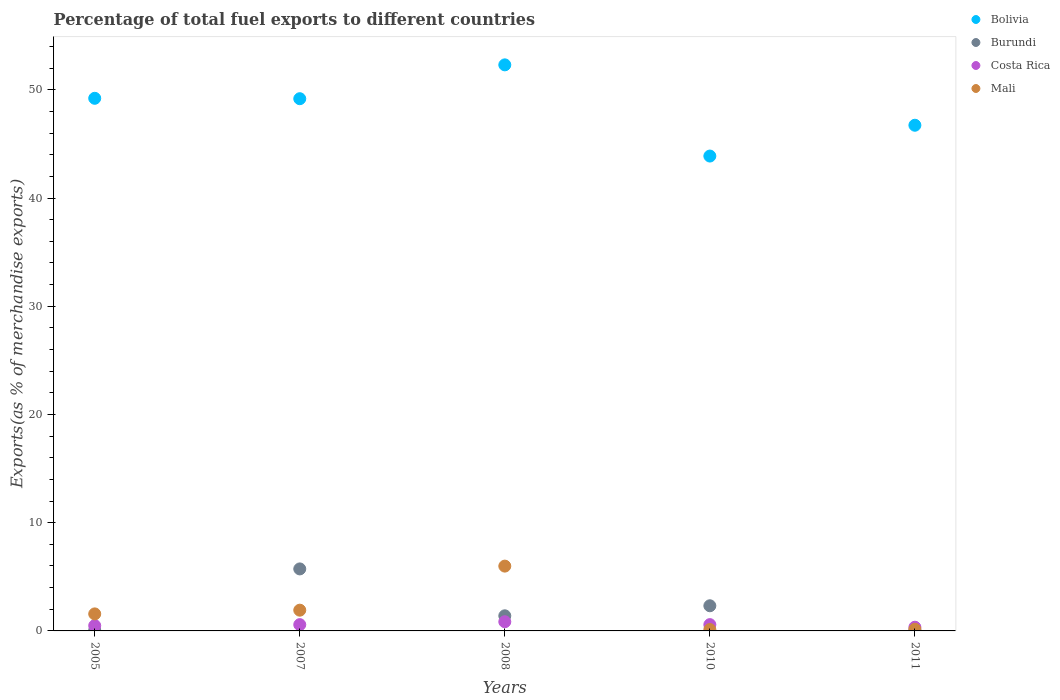What is the percentage of exports to different countries in Costa Rica in 2010?
Give a very brief answer. 0.58. Across all years, what is the maximum percentage of exports to different countries in Mali?
Your response must be concise. 5.99. Across all years, what is the minimum percentage of exports to different countries in Costa Rica?
Make the answer very short. 0.34. In which year was the percentage of exports to different countries in Costa Rica maximum?
Offer a terse response. 2008. In which year was the percentage of exports to different countries in Mali minimum?
Your answer should be very brief. 2010. What is the total percentage of exports to different countries in Burundi in the graph?
Offer a terse response. 9.55. What is the difference between the percentage of exports to different countries in Bolivia in 2010 and that in 2011?
Ensure brevity in your answer.  -2.85. What is the difference between the percentage of exports to different countries in Costa Rica in 2011 and the percentage of exports to different countries in Bolivia in 2010?
Ensure brevity in your answer.  -43.54. What is the average percentage of exports to different countries in Costa Rica per year?
Make the answer very short. 0.57. In the year 2010, what is the difference between the percentage of exports to different countries in Bolivia and percentage of exports to different countries in Mali?
Give a very brief answer. 43.75. In how many years, is the percentage of exports to different countries in Costa Rica greater than 46 %?
Make the answer very short. 0. What is the ratio of the percentage of exports to different countries in Bolivia in 2010 to that in 2011?
Provide a succinct answer. 0.94. Is the percentage of exports to different countries in Mali in 2008 less than that in 2010?
Offer a terse response. No. What is the difference between the highest and the second highest percentage of exports to different countries in Burundi?
Ensure brevity in your answer.  3.41. What is the difference between the highest and the lowest percentage of exports to different countries in Mali?
Give a very brief answer. 5.86. In how many years, is the percentage of exports to different countries in Costa Rica greater than the average percentage of exports to different countries in Costa Rica taken over all years?
Offer a very short reply. 3. Is it the case that in every year, the sum of the percentage of exports to different countries in Mali and percentage of exports to different countries in Costa Rica  is greater than the percentage of exports to different countries in Bolivia?
Keep it short and to the point. No. Does the percentage of exports to different countries in Bolivia monotonically increase over the years?
Make the answer very short. No. Is the percentage of exports to different countries in Burundi strictly greater than the percentage of exports to different countries in Mali over the years?
Your response must be concise. No. Is the percentage of exports to different countries in Mali strictly less than the percentage of exports to different countries in Bolivia over the years?
Offer a very short reply. Yes. How many dotlines are there?
Make the answer very short. 4. How many years are there in the graph?
Provide a short and direct response. 5. Does the graph contain grids?
Offer a very short reply. No. Where does the legend appear in the graph?
Your response must be concise. Top right. How are the legend labels stacked?
Make the answer very short. Vertical. What is the title of the graph?
Your response must be concise. Percentage of total fuel exports to different countries. Does "Euro area" appear as one of the legend labels in the graph?
Offer a terse response. No. What is the label or title of the Y-axis?
Provide a succinct answer. Exports(as % of merchandise exports). What is the Exports(as % of merchandise exports) of Bolivia in 2005?
Your answer should be compact. 49.21. What is the Exports(as % of merchandise exports) in Burundi in 2005?
Your answer should be very brief. 0.06. What is the Exports(as % of merchandise exports) of Costa Rica in 2005?
Ensure brevity in your answer.  0.49. What is the Exports(as % of merchandise exports) in Mali in 2005?
Offer a terse response. 1.57. What is the Exports(as % of merchandise exports) in Bolivia in 2007?
Ensure brevity in your answer.  49.18. What is the Exports(as % of merchandise exports) in Burundi in 2007?
Ensure brevity in your answer.  5.73. What is the Exports(as % of merchandise exports) of Costa Rica in 2007?
Your answer should be very brief. 0.58. What is the Exports(as % of merchandise exports) in Mali in 2007?
Provide a short and direct response. 1.92. What is the Exports(as % of merchandise exports) in Bolivia in 2008?
Offer a terse response. 52.3. What is the Exports(as % of merchandise exports) in Burundi in 2008?
Provide a succinct answer. 1.4. What is the Exports(as % of merchandise exports) of Costa Rica in 2008?
Your answer should be very brief. 0.85. What is the Exports(as % of merchandise exports) of Mali in 2008?
Offer a terse response. 5.99. What is the Exports(as % of merchandise exports) in Bolivia in 2010?
Keep it short and to the point. 43.88. What is the Exports(as % of merchandise exports) in Burundi in 2010?
Make the answer very short. 2.32. What is the Exports(as % of merchandise exports) of Costa Rica in 2010?
Provide a succinct answer. 0.58. What is the Exports(as % of merchandise exports) of Mali in 2010?
Your answer should be very brief. 0.13. What is the Exports(as % of merchandise exports) in Bolivia in 2011?
Provide a short and direct response. 46.72. What is the Exports(as % of merchandise exports) of Burundi in 2011?
Offer a very short reply. 0.04. What is the Exports(as % of merchandise exports) of Costa Rica in 2011?
Offer a very short reply. 0.34. What is the Exports(as % of merchandise exports) in Mali in 2011?
Your answer should be compact. 0.15. Across all years, what is the maximum Exports(as % of merchandise exports) of Bolivia?
Offer a very short reply. 52.3. Across all years, what is the maximum Exports(as % of merchandise exports) of Burundi?
Make the answer very short. 5.73. Across all years, what is the maximum Exports(as % of merchandise exports) in Costa Rica?
Your answer should be compact. 0.85. Across all years, what is the maximum Exports(as % of merchandise exports) in Mali?
Your answer should be very brief. 5.99. Across all years, what is the minimum Exports(as % of merchandise exports) of Bolivia?
Give a very brief answer. 43.88. Across all years, what is the minimum Exports(as % of merchandise exports) of Burundi?
Your response must be concise. 0.04. Across all years, what is the minimum Exports(as % of merchandise exports) in Costa Rica?
Your answer should be very brief. 0.34. Across all years, what is the minimum Exports(as % of merchandise exports) in Mali?
Make the answer very short. 0.13. What is the total Exports(as % of merchandise exports) in Bolivia in the graph?
Provide a succinct answer. 241.3. What is the total Exports(as % of merchandise exports) in Burundi in the graph?
Ensure brevity in your answer.  9.55. What is the total Exports(as % of merchandise exports) of Costa Rica in the graph?
Offer a terse response. 2.84. What is the total Exports(as % of merchandise exports) in Mali in the graph?
Your response must be concise. 9.76. What is the difference between the Exports(as % of merchandise exports) in Bolivia in 2005 and that in 2007?
Make the answer very short. 0.04. What is the difference between the Exports(as % of merchandise exports) of Burundi in 2005 and that in 2007?
Your response must be concise. -5.67. What is the difference between the Exports(as % of merchandise exports) in Costa Rica in 2005 and that in 2007?
Make the answer very short. -0.09. What is the difference between the Exports(as % of merchandise exports) of Mali in 2005 and that in 2007?
Make the answer very short. -0.34. What is the difference between the Exports(as % of merchandise exports) in Bolivia in 2005 and that in 2008?
Your answer should be compact. -3.09. What is the difference between the Exports(as % of merchandise exports) in Burundi in 2005 and that in 2008?
Offer a very short reply. -1.33. What is the difference between the Exports(as % of merchandise exports) of Costa Rica in 2005 and that in 2008?
Provide a succinct answer. -0.36. What is the difference between the Exports(as % of merchandise exports) of Mali in 2005 and that in 2008?
Give a very brief answer. -4.42. What is the difference between the Exports(as % of merchandise exports) of Bolivia in 2005 and that in 2010?
Ensure brevity in your answer.  5.34. What is the difference between the Exports(as % of merchandise exports) of Burundi in 2005 and that in 2010?
Give a very brief answer. -2.26. What is the difference between the Exports(as % of merchandise exports) of Costa Rica in 2005 and that in 2010?
Ensure brevity in your answer.  -0.09. What is the difference between the Exports(as % of merchandise exports) of Mali in 2005 and that in 2010?
Offer a very short reply. 1.45. What is the difference between the Exports(as % of merchandise exports) of Bolivia in 2005 and that in 2011?
Ensure brevity in your answer.  2.49. What is the difference between the Exports(as % of merchandise exports) of Burundi in 2005 and that in 2011?
Provide a succinct answer. 0.03. What is the difference between the Exports(as % of merchandise exports) in Costa Rica in 2005 and that in 2011?
Offer a terse response. 0.15. What is the difference between the Exports(as % of merchandise exports) of Mali in 2005 and that in 2011?
Keep it short and to the point. 1.42. What is the difference between the Exports(as % of merchandise exports) in Bolivia in 2007 and that in 2008?
Offer a very short reply. -3.13. What is the difference between the Exports(as % of merchandise exports) of Burundi in 2007 and that in 2008?
Make the answer very short. 4.33. What is the difference between the Exports(as % of merchandise exports) of Costa Rica in 2007 and that in 2008?
Offer a very short reply. -0.27. What is the difference between the Exports(as % of merchandise exports) of Mali in 2007 and that in 2008?
Your response must be concise. -4.07. What is the difference between the Exports(as % of merchandise exports) in Bolivia in 2007 and that in 2010?
Provide a short and direct response. 5.3. What is the difference between the Exports(as % of merchandise exports) of Burundi in 2007 and that in 2010?
Keep it short and to the point. 3.41. What is the difference between the Exports(as % of merchandise exports) in Costa Rica in 2007 and that in 2010?
Offer a terse response. -0. What is the difference between the Exports(as % of merchandise exports) of Mali in 2007 and that in 2010?
Your answer should be compact. 1.79. What is the difference between the Exports(as % of merchandise exports) in Bolivia in 2007 and that in 2011?
Offer a very short reply. 2.45. What is the difference between the Exports(as % of merchandise exports) of Burundi in 2007 and that in 2011?
Give a very brief answer. 5.69. What is the difference between the Exports(as % of merchandise exports) of Costa Rica in 2007 and that in 2011?
Keep it short and to the point. 0.24. What is the difference between the Exports(as % of merchandise exports) in Mali in 2007 and that in 2011?
Keep it short and to the point. 1.76. What is the difference between the Exports(as % of merchandise exports) in Bolivia in 2008 and that in 2010?
Provide a short and direct response. 8.43. What is the difference between the Exports(as % of merchandise exports) in Burundi in 2008 and that in 2010?
Offer a very short reply. -0.93. What is the difference between the Exports(as % of merchandise exports) in Costa Rica in 2008 and that in 2010?
Ensure brevity in your answer.  0.27. What is the difference between the Exports(as % of merchandise exports) of Mali in 2008 and that in 2010?
Offer a very short reply. 5.86. What is the difference between the Exports(as % of merchandise exports) of Bolivia in 2008 and that in 2011?
Your answer should be compact. 5.58. What is the difference between the Exports(as % of merchandise exports) of Burundi in 2008 and that in 2011?
Offer a very short reply. 1.36. What is the difference between the Exports(as % of merchandise exports) of Costa Rica in 2008 and that in 2011?
Make the answer very short. 0.51. What is the difference between the Exports(as % of merchandise exports) of Mali in 2008 and that in 2011?
Provide a succinct answer. 5.83. What is the difference between the Exports(as % of merchandise exports) in Bolivia in 2010 and that in 2011?
Make the answer very short. -2.85. What is the difference between the Exports(as % of merchandise exports) in Burundi in 2010 and that in 2011?
Give a very brief answer. 2.29. What is the difference between the Exports(as % of merchandise exports) of Costa Rica in 2010 and that in 2011?
Offer a terse response. 0.24. What is the difference between the Exports(as % of merchandise exports) of Mali in 2010 and that in 2011?
Keep it short and to the point. -0.03. What is the difference between the Exports(as % of merchandise exports) of Bolivia in 2005 and the Exports(as % of merchandise exports) of Burundi in 2007?
Your response must be concise. 43.48. What is the difference between the Exports(as % of merchandise exports) of Bolivia in 2005 and the Exports(as % of merchandise exports) of Costa Rica in 2007?
Your response must be concise. 48.63. What is the difference between the Exports(as % of merchandise exports) in Bolivia in 2005 and the Exports(as % of merchandise exports) in Mali in 2007?
Make the answer very short. 47.3. What is the difference between the Exports(as % of merchandise exports) in Burundi in 2005 and the Exports(as % of merchandise exports) in Costa Rica in 2007?
Your answer should be very brief. -0.52. What is the difference between the Exports(as % of merchandise exports) in Burundi in 2005 and the Exports(as % of merchandise exports) in Mali in 2007?
Your response must be concise. -1.85. What is the difference between the Exports(as % of merchandise exports) in Costa Rica in 2005 and the Exports(as % of merchandise exports) in Mali in 2007?
Provide a succinct answer. -1.43. What is the difference between the Exports(as % of merchandise exports) in Bolivia in 2005 and the Exports(as % of merchandise exports) in Burundi in 2008?
Provide a succinct answer. 47.82. What is the difference between the Exports(as % of merchandise exports) of Bolivia in 2005 and the Exports(as % of merchandise exports) of Costa Rica in 2008?
Offer a terse response. 48.37. What is the difference between the Exports(as % of merchandise exports) in Bolivia in 2005 and the Exports(as % of merchandise exports) in Mali in 2008?
Offer a very short reply. 43.23. What is the difference between the Exports(as % of merchandise exports) of Burundi in 2005 and the Exports(as % of merchandise exports) of Costa Rica in 2008?
Provide a short and direct response. -0.78. What is the difference between the Exports(as % of merchandise exports) in Burundi in 2005 and the Exports(as % of merchandise exports) in Mali in 2008?
Give a very brief answer. -5.92. What is the difference between the Exports(as % of merchandise exports) in Costa Rica in 2005 and the Exports(as % of merchandise exports) in Mali in 2008?
Provide a succinct answer. -5.5. What is the difference between the Exports(as % of merchandise exports) in Bolivia in 2005 and the Exports(as % of merchandise exports) in Burundi in 2010?
Your answer should be very brief. 46.89. What is the difference between the Exports(as % of merchandise exports) of Bolivia in 2005 and the Exports(as % of merchandise exports) of Costa Rica in 2010?
Make the answer very short. 48.63. What is the difference between the Exports(as % of merchandise exports) in Bolivia in 2005 and the Exports(as % of merchandise exports) in Mali in 2010?
Your response must be concise. 49.09. What is the difference between the Exports(as % of merchandise exports) in Burundi in 2005 and the Exports(as % of merchandise exports) in Costa Rica in 2010?
Your answer should be very brief. -0.52. What is the difference between the Exports(as % of merchandise exports) of Burundi in 2005 and the Exports(as % of merchandise exports) of Mali in 2010?
Ensure brevity in your answer.  -0.06. What is the difference between the Exports(as % of merchandise exports) of Costa Rica in 2005 and the Exports(as % of merchandise exports) of Mali in 2010?
Offer a very short reply. 0.36. What is the difference between the Exports(as % of merchandise exports) of Bolivia in 2005 and the Exports(as % of merchandise exports) of Burundi in 2011?
Provide a short and direct response. 49.18. What is the difference between the Exports(as % of merchandise exports) of Bolivia in 2005 and the Exports(as % of merchandise exports) of Costa Rica in 2011?
Offer a very short reply. 48.87. What is the difference between the Exports(as % of merchandise exports) of Bolivia in 2005 and the Exports(as % of merchandise exports) of Mali in 2011?
Offer a terse response. 49.06. What is the difference between the Exports(as % of merchandise exports) in Burundi in 2005 and the Exports(as % of merchandise exports) in Costa Rica in 2011?
Keep it short and to the point. -0.28. What is the difference between the Exports(as % of merchandise exports) of Burundi in 2005 and the Exports(as % of merchandise exports) of Mali in 2011?
Provide a succinct answer. -0.09. What is the difference between the Exports(as % of merchandise exports) of Costa Rica in 2005 and the Exports(as % of merchandise exports) of Mali in 2011?
Offer a very short reply. 0.34. What is the difference between the Exports(as % of merchandise exports) in Bolivia in 2007 and the Exports(as % of merchandise exports) in Burundi in 2008?
Your response must be concise. 47.78. What is the difference between the Exports(as % of merchandise exports) in Bolivia in 2007 and the Exports(as % of merchandise exports) in Costa Rica in 2008?
Provide a succinct answer. 48.33. What is the difference between the Exports(as % of merchandise exports) of Bolivia in 2007 and the Exports(as % of merchandise exports) of Mali in 2008?
Ensure brevity in your answer.  43.19. What is the difference between the Exports(as % of merchandise exports) in Burundi in 2007 and the Exports(as % of merchandise exports) in Costa Rica in 2008?
Your answer should be compact. 4.88. What is the difference between the Exports(as % of merchandise exports) of Burundi in 2007 and the Exports(as % of merchandise exports) of Mali in 2008?
Provide a succinct answer. -0.26. What is the difference between the Exports(as % of merchandise exports) in Costa Rica in 2007 and the Exports(as % of merchandise exports) in Mali in 2008?
Provide a succinct answer. -5.41. What is the difference between the Exports(as % of merchandise exports) of Bolivia in 2007 and the Exports(as % of merchandise exports) of Burundi in 2010?
Give a very brief answer. 46.85. What is the difference between the Exports(as % of merchandise exports) of Bolivia in 2007 and the Exports(as % of merchandise exports) of Costa Rica in 2010?
Offer a terse response. 48.59. What is the difference between the Exports(as % of merchandise exports) in Bolivia in 2007 and the Exports(as % of merchandise exports) in Mali in 2010?
Provide a succinct answer. 49.05. What is the difference between the Exports(as % of merchandise exports) of Burundi in 2007 and the Exports(as % of merchandise exports) of Costa Rica in 2010?
Provide a succinct answer. 5.15. What is the difference between the Exports(as % of merchandise exports) in Burundi in 2007 and the Exports(as % of merchandise exports) in Mali in 2010?
Your answer should be very brief. 5.6. What is the difference between the Exports(as % of merchandise exports) of Costa Rica in 2007 and the Exports(as % of merchandise exports) of Mali in 2010?
Ensure brevity in your answer.  0.45. What is the difference between the Exports(as % of merchandise exports) in Bolivia in 2007 and the Exports(as % of merchandise exports) in Burundi in 2011?
Your answer should be very brief. 49.14. What is the difference between the Exports(as % of merchandise exports) of Bolivia in 2007 and the Exports(as % of merchandise exports) of Costa Rica in 2011?
Offer a very short reply. 48.83. What is the difference between the Exports(as % of merchandise exports) of Bolivia in 2007 and the Exports(as % of merchandise exports) of Mali in 2011?
Your answer should be compact. 49.02. What is the difference between the Exports(as % of merchandise exports) in Burundi in 2007 and the Exports(as % of merchandise exports) in Costa Rica in 2011?
Offer a terse response. 5.39. What is the difference between the Exports(as % of merchandise exports) of Burundi in 2007 and the Exports(as % of merchandise exports) of Mali in 2011?
Provide a succinct answer. 5.58. What is the difference between the Exports(as % of merchandise exports) of Costa Rica in 2007 and the Exports(as % of merchandise exports) of Mali in 2011?
Ensure brevity in your answer.  0.43. What is the difference between the Exports(as % of merchandise exports) in Bolivia in 2008 and the Exports(as % of merchandise exports) in Burundi in 2010?
Keep it short and to the point. 49.98. What is the difference between the Exports(as % of merchandise exports) of Bolivia in 2008 and the Exports(as % of merchandise exports) of Costa Rica in 2010?
Your answer should be very brief. 51.72. What is the difference between the Exports(as % of merchandise exports) in Bolivia in 2008 and the Exports(as % of merchandise exports) in Mali in 2010?
Offer a terse response. 52.18. What is the difference between the Exports(as % of merchandise exports) in Burundi in 2008 and the Exports(as % of merchandise exports) in Costa Rica in 2010?
Your answer should be very brief. 0.81. What is the difference between the Exports(as % of merchandise exports) of Burundi in 2008 and the Exports(as % of merchandise exports) of Mali in 2010?
Provide a short and direct response. 1.27. What is the difference between the Exports(as % of merchandise exports) of Costa Rica in 2008 and the Exports(as % of merchandise exports) of Mali in 2010?
Your answer should be compact. 0.72. What is the difference between the Exports(as % of merchandise exports) in Bolivia in 2008 and the Exports(as % of merchandise exports) in Burundi in 2011?
Offer a terse response. 52.27. What is the difference between the Exports(as % of merchandise exports) of Bolivia in 2008 and the Exports(as % of merchandise exports) of Costa Rica in 2011?
Offer a very short reply. 51.96. What is the difference between the Exports(as % of merchandise exports) of Bolivia in 2008 and the Exports(as % of merchandise exports) of Mali in 2011?
Your answer should be very brief. 52.15. What is the difference between the Exports(as % of merchandise exports) in Burundi in 2008 and the Exports(as % of merchandise exports) in Costa Rica in 2011?
Keep it short and to the point. 1.05. What is the difference between the Exports(as % of merchandise exports) in Burundi in 2008 and the Exports(as % of merchandise exports) in Mali in 2011?
Your response must be concise. 1.24. What is the difference between the Exports(as % of merchandise exports) in Costa Rica in 2008 and the Exports(as % of merchandise exports) in Mali in 2011?
Give a very brief answer. 0.69. What is the difference between the Exports(as % of merchandise exports) in Bolivia in 2010 and the Exports(as % of merchandise exports) in Burundi in 2011?
Make the answer very short. 43.84. What is the difference between the Exports(as % of merchandise exports) in Bolivia in 2010 and the Exports(as % of merchandise exports) in Costa Rica in 2011?
Your answer should be very brief. 43.54. What is the difference between the Exports(as % of merchandise exports) in Bolivia in 2010 and the Exports(as % of merchandise exports) in Mali in 2011?
Keep it short and to the point. 43.72. What is the difference between the Exports(as % of merchandise exports) in Burundi in 2010 and the Exports(as % of merchandise exports) in Costa Rica in 2011?
Give a very brief answer. 1.98. What is the difference between the Exports(as % of merchandise exports) in Burundi in 2010 and the Exports(as % of merchandise exports) in Mali in 2011?
Provide a succinct answer. 2.17. What is the difference between the Exports(as % of merchandise exports) in Costa Rica in 2010 and the Exports(as % of merchandise exports) in Mali in 2011?
Ensure brevity in your answer.  0.43. What is the average Exports(as % of merchandise exports) in Bolivia per year?
Give a very brief answer. 48.26. What is the average Exports(as % of merchandise exports) of Burundi per year?
Your response must be concise. 1.91. What is the average Exports(as % of merchandise exports) in Costa Rica per year?
Ensure brevity in your answer.  0.57. What is the average Exports(as % of merchandise exports) of Mali per year?
Keep it short and to the point. 1.95. In the year 2005, what is the difference between the Exports(as % of merchandise exports) in Bolivia and Exports(as % of merchandise exports) in Burundi?
Offer a terse response. 49.15. In the year 2005, what is the difference between the Exports(as % of merchandise exports) in Bolivia and Exports(as % of merchandise exports) in Costa Rica?
Provide a succinct answer. 48.72. In the year 2005, what is the difference between the Exports(as % of merchandise exports) of Bolivia and Exports(as % of merchandise exports) of Mali?
Your answer should be compact. 47.64. In the year 2005, what is the difference between the Exports(as % of merchandise exports) in Burundi and Exports(as % of merchandise exports) in Costa Rica?
Your response must be concise. -0.43. In the year 2005, what is the difference between the Exports(as % of merchandise exports) of Burundi and Exports(as % of merchandise exports) of Mali?
Give a very brief answer. -1.51. In the year 2005, what is the difference between the Exports(as % of merchandise exports) in Costa Rica and Exports(as % of merchandise exports) in Mali?
Your answer should be very brief. -1.08. In the year 2007, what is the difference between the Exports(as % of merchandise exports) of Bolivia and Exports(as % of merchandise exports) of Burundi?
Offer a very short reply. 43.45. In the year 2007, what is the difference between the Exports(as % of merchandise exports) of Bolivia and Exports(as % of merchandise exports) of Costa Rica?
Your answer should be very brief. 48.6. In the year 2007, what is the difference between the Exports(as % of merchandise exports) of Bolivia and Exports(as % of merchandise exports) of Mali?
Ensure brevity in your answer.  47.26. In the year 2007, what is the difference between the Exports(as % of merchandise exports) of Burundi and Exports(as % of merchandise exports) of Costa Rica?
Provide a succinct answer. 5.15. In the year 2007, what is the difference between the Exports(as % of merchandise exports) in Burundi and Exports(as % of merchandise exports) in Mali?
Ensure brevity in your answer.  3.81. In the year 2007, what is the difference between the Exports(as % of merchandise exports) in Costa Rica and Exports(as % of merchandise exports) in Mali?
Ensure brevity in your answer.  -1.34. In the year 2008, what is the difference between the Exports(as % of merchandise exports) in Bolivia and Exports(as % of merchandise exports) in Burundi?
Give a very brief answer. 50.91. In the year 2008, what is the difference between the Exports(as % of merchandise exports) of Bolivia and Exports(as % of merchandise exports) of Costa Rica?
Keep it short and to the point. 51.45. In the year 2008, what is the difference between the Exports(as % of merchandise exports) in Bolivia and Exports(as % of merchandise exports) in Mali?
Provide a short and direct response. 46.32. In the year 2008, what is the difference between the Exports(as % of merchandise exports) of Burundi and Exports(as % of merchandise exports) of Costa Rica?
Offer a terse response. 0.55. In the year 2008, what is the difference between the Exports(as % of merchandise exports) of Burundi and Exports(as % of merchandise exports) of Mali?
Provide a succinct answer. -4.59. In the year 2008, what is the difference between the Exports(as % of merchandise exports) of Costa Rica and Exports(as % of merchandise exports) of Mali?
Ensure brevity in your answer.  -5.14. In the year 2010, what is the difference between the Exports(as % of merchandise exports) in Bolivia and Exports(as % of merchandise exports) in Burundi?
Your response must be concise. 41.55. In the year 2010, what is the difference between the Exports(as % of merchandise exports) of Bolivia and Exports(as % of merchandise exports) of Costa Rica?
Offer a terse response. 43.3. In the year 2010, what is the difference between the Exports(as % of merchandise exports) in Bolivia and Exports(as % of merchandise exports) in Mali?
Make the answer very short. 43.75. In the year 2010, what is the difference between the Exports(as % of merchandise exports) of Burundi and Exports(as % of merchandise exports) of Costa Rica?
Give a very brief answer. 1.74. In the year 2010, what is the difference between the Exports(as % of merchandise exports) in Burundi and Exports(as % of merchandise exports) in Mali?
Provide a short and direct response. 2.2. In the year 2010, what is the difference between the Exports(as % of merchandise exports) of Costa Rica and Exports(as % of merchandise exports) of Mali?
Offer a very short reply. 0.45. In the year 2011, what is the difference between the Exports(as % of merchandise exports) of Bolivia and Exports(as % of merchandise exports) of Burundi?
Keep it short and to the point. 46.69. In the year 2011, what is the difference between the Exports(as % of merchandise exports) of Bolivia and Exports(as % of merchandise exports) of Costa Rica?
Your response must be concise. 46.38. In the year 2011, what is the difference between the Exports(as % of merchandise exports) of Bolivia and Exports(as % of merchandise exports) of Mali?
Your answer should be compact. 46.57. In the year 2011, what is the difference between the Exports(as % of merchandise exports) of Burundi and Exports(as % of merchandise exports) of Costa Rica?
Offer a very short reply. -0.31. In the year 2011, what is the difference between the Exports(as % of merchandise exports) in Burundi and Exports(as % of merchandise exports) in Mali?
Make the answer very short. -0.12. In the year 2011, what is the difference between the Exports(as % of merchandise exports) in Costa Rica and Exports(as % of merchandise exports) in Mali?
Your response must be concise. 0.19. What is the ratio of the Exports(as % of merchandise exports) of Bolivia in 2005 to that in 2007?
Provide a short and direct response. 1. What is the ratio of the Exports(as % of merchandise exports) in Burundi in 2005 to that in 2007?
Offer a very short reply. 0.01. What is the ratio of the Exports(as % of merchandise exports) of Costa Rica in 2005 to that in 2007?
Your response must be concise. 0.84. What is the ratio of the Exports(as % of merchandise exports) of Mali in 2005 to that in 2007?
Give a very brief answer. 0.82. What is the ratio of the Exports(as % of merchandise exports) in Bolivia in 2005 to that in 2008?
Make the answer very short. 0.94. What is the ratio of the Exports(as % of merchandise exports) of Burundi in 2005 to that in 2008?
Make the answer very short. 0.05. What is the ratio of the Exports(as % of merchandise exports) of Costa Rica in 2005 to that in 2008?
Give a very brief answer. 0.58. What is the ratio of the Exports(as % of merchandise exports) of Mali in 2005 to that in 2008?
Provide a short and direct response. 0.26. What is the ratio of the Exports(as % of merchandise exports) in Bolivia in 2005 to that in 2010?
Keep it short and to the point. 1.12. What is the ratio of the Exports(as % of merchandise exports) in Burundi in 2005 to that in 2010?
Your answer should be very brief. 0.03. What is the ratio of the Exports(as % of merchandise exports) in Costa Rica in 2005 to that in 2010?
Ensure brevity in your answer.  0.84. What is the ratio of the Exports(as % of merchandise exports) in Mali in 2005 to that in 2010?
Make the answer very short. 12.37. What is the ratio of the Exports(as % of merchandise exports) in Bolivia in 2005 to that in 2011?
Give a very brief answer. 1.05. What is the ratio of the Exports(as % of merchandise exports) in Burundi in 2005 to that in 2011?
Keep it short and to the point. 1.77. What is the ratio of the Exports(as % of merchandise exports) in Costa Rica in 2005 to that in 2011?
Offer a very short reply. 1.43. What is the ratio of the Exports(as % of merchandise exports) of Mali in 2005 to that in 2011?
Give a very brief answer. 10.17. What is the ratio of the Exports(as % of merchandise exports) in Bolivia in 2007 to that in 2008?
Give a very brief answer. 0.94. What is the ratio of the Exports(as % of merchandise exports) of Burundi in 2007 to that in 2008?
Provide a succinct answer. 4.1. What is the ratio of the Exports(as % of merchandise exports) of Costa Rica in 2007 to that in 2008?
Your answer should be very brief. 0.68. What is the ratio of the Exports(as % of merchandise exports) in Mali in 2007 to that in 2008?
Keep it short and to the point. 0.32. What is the ratio of the Exports(as % of merchandise exports) in Bolivia in 2007 to that in 2010?
Ensure brevity in your answer.  1.12. What is the ratio of the Exports(as % of merchandise exports) in Burundi in 2007 to that in 2010?
Offer a very short reply. 2.47. What is the ratio of the Exports(as % of merchandise exports) of Mali in 2007 to that in 2010?
Keep it short and to the point. 15.07. What is the ratio of the Exports(as % of merchandise exports) in Bolivia in 2007 to that in 2011?
Make the answer very short. 1.05. What is the ratio of the Exports(as % of merchandise exports) in Burundi in 2007 to that in 2011?
Provide a succinct answer. 158.2. What is the ratio of the Exports(as % of merchandise exports) in Costa Rica in 2007 to that in 2011?
Your answer should be compact. 1.7. What is the ratio of the Exports(as % of merchandise exports) of Mali in 2007 to that in 2011?
Provide a succinct answer. 12.39. What is the ratio of the Exports(as % of merchandise exports) in Bolivia in 2008 to that in 2010?
Ensure brevity in your answer.  1.19. What is the ratio of the Exports(as % of merchandise exports) in Burundi in 2008 to that in 2010?
Offer a very short reply. 0.6. What is the ratio of the Exports(as % of merchandise exports) in Costa Rica in 2008 to that in 2010?
Make the answer very short. 1.46. What is the ratio of the Exports(as % of merchandise exports) of Mali in 2008 to that in 2010?
Ensure brevity in your answer.  47.08. What is the ratio of the Exports(as % of merchandise exports) of Bolivia in 2008 to that in 2011?
Offer a very short reply. 1.12. What is the ratio of the Exports(as % of merchandise exports) of Burundi in 2008 to that in 2011?
Ensure brevity in your answer.  38.55. What is the ratio of the Exports(as % of merchandise exports) in Costa Rica in 2008 to that in 2011?
Ensure brevity in your answer.  2.48. What is the ratio of the Exports(as % of merchandise exports) in Mali in 2008 to that in 2011?
Give a very brief answer. 38.71. What is the ratio of the Exports(as % of merchandise exports) in Bolivia in 2010 to that in 2011?
Your answer should be compact. 0.94. What is the ratio of the Exports(as % of merchandise exports) of Burundi in 2010 to that in 2011?
Your answer should be very brief. 64.18. What is the ratio of the Exports(as % of merchandise exports) of Costa Rica in 2010 to that in 2011?
Your answer should be very brief. 1.7. What is the ratio of the Exports(as % of merchandise exports) in Mali in 2010 to that in 2011?
Give a very brief answer. 0.82. What is the difference between the highest and the second highest Exports(as % of merchandise exports) of Bolivia?
Keep it short and to the point. 3.09. What is the difference between the highest and the second highest Exports(as % of merchandise exports) in Burundi?
Provide a short and direct response. 3.41. What is the difference between the highest and the second highest Exports(as % of merchandise exports) in Costa Rica?
Your response must be concise. 0.27. What is the difference between the highest and the second highest Exports(as % of merchandise exports) in Mali?
Offer a very short reply. 4.07. What is the difference between the highest and the lowest Exports(as % of merchandise exports) of Bolivia?
Your answer should be very brief. 8.43. What is the difference between the highest and the lowest Exports(as % of merchandise exports) in Burundi?
Your answer should be compact. 5.69. What is the difference between the highest and the lowest Exports(as % of merchandise exports) of Costa Rica?
Provide a succinct answer. 0.51. What is the difference between the highest and the lowest Exports(as % of merchandise exports) of Mali?
Give a very brief answer. 5.86. 